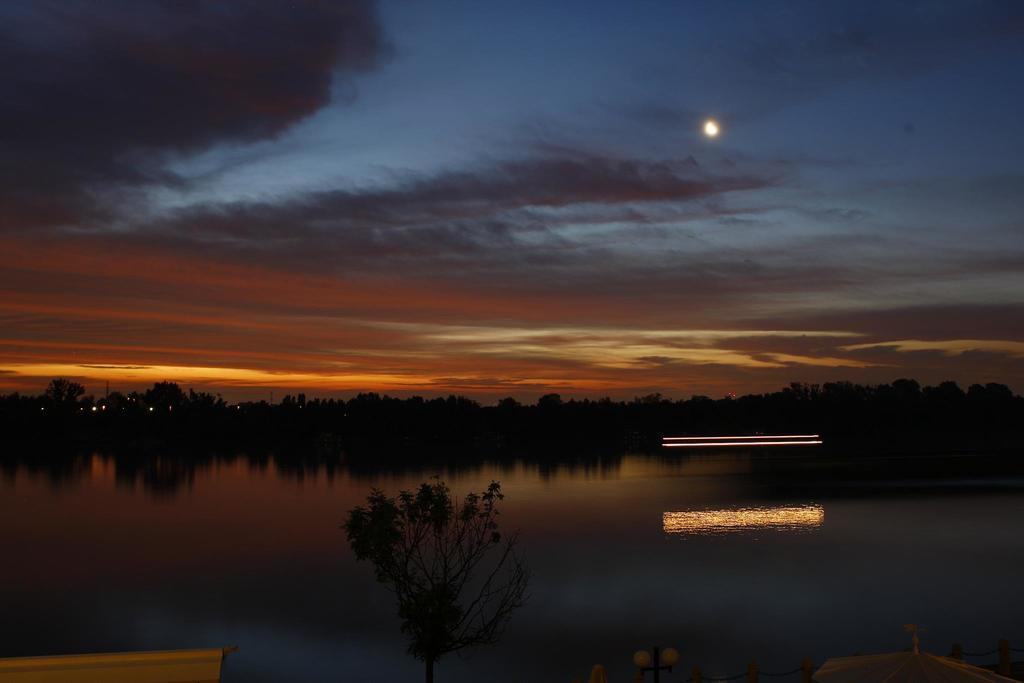Please provide a concise description of this image. This picture is taken in the dark, where we can see the water, trees, lights and in the background, I can see the moon and the clouds in the dark sky 